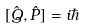Convert formula to latex. <formula><loc_0><loc_0><loc_500><loc_500>[ { \hat { Q } } , { \hat { P } } ] = i \hbar</formula> 